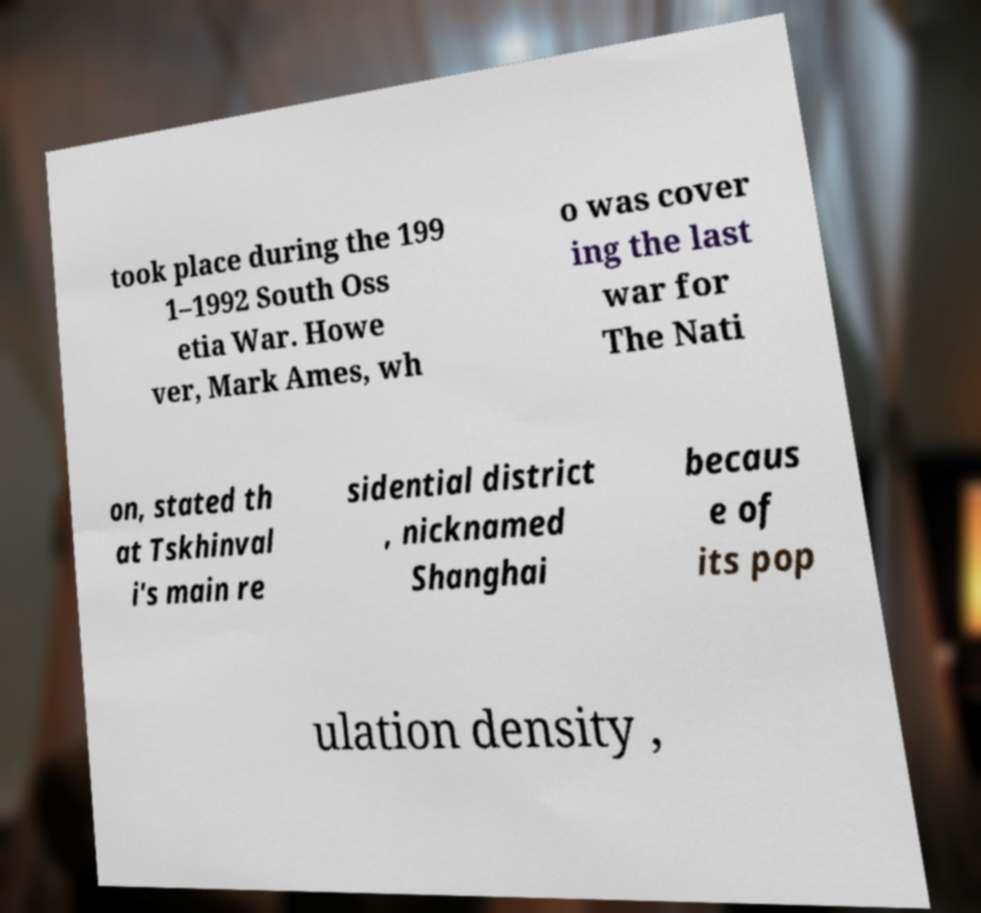For documentation purposes, I need the text within this image transcribed. Could you provide that? took place during the 199 1–1992 South Oss etia War. Howe ver, Mark Ames, wh o was cover ing the last war for The Nati on, stated th at Tskhinval i's main re sidential district , nicknamed Shanghai becaus e of its pop ulation density , 